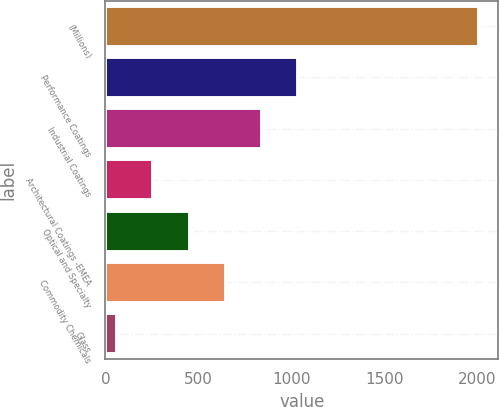<chart> <loc_0><loc_0><loc_500><loc_500><bar_chart><fcel>(Millions)<fcel>Performance Coatings<fcel>Industrial Coatings<fcel>Architectural Coatings -EMEA<fcel>Optical and Specialty<fcel>Commodity Chemicals<fcel>Glass<nl><fcel>2012<fcel>1037.5<fcel>842.6<fcel>257.9<fcel>452.8<fcel>647.7<fcel>63<nl></chart> 